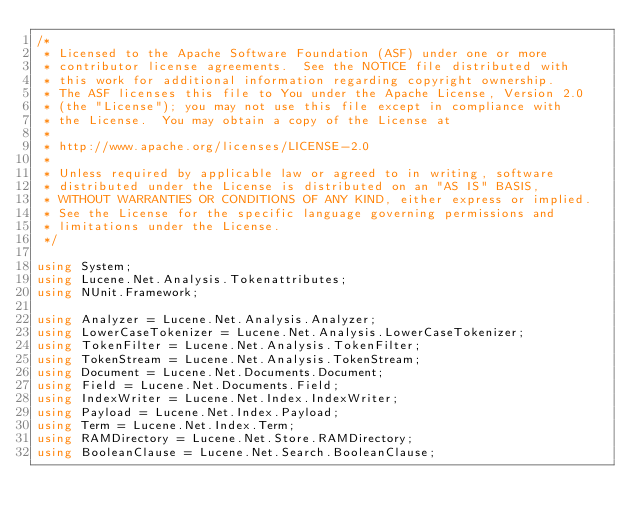Convert code to text. <code><loc_0><loc_0><loc_500><loc_500><_C#_>/* 
 * Licensed to the Apache Software Foundation (ASF) under one or more
 * contributor license agreements.  See the NOTICE file distributed with
 * this work for additional information regarding copyright ownership.
 * The ASF licenses this file to You under the Apache License, Version 2.0
 * (the "License"); you may not use this file except in compliance with
 * the License.  You may obtain a copy of the License at
 * 
 * http://www.apache.org/licenses/LICENSE-2.0
 * 
 * Unless required by applicable law or agreed to in writing, software
 * distributed under the License is distributed on an "AS IS" BASIS,
 * WITHOUT WARRANTIES OR CONDITIONS OF ANY KIND, either express or implied.
 * See the License for the specific language governing permissions and
 * limitations under the License.
 */

using System;
using Lucene.Net.Analysis.Tokenattributes;
using NUnit.Framework;

using Analyzer = Lucene.Net.Analysis.Analyzer;
using LowerCaseTokenizer = Lucene.Net.Analysis.LowerCaseTokenizer;
using TokenFilter = Lucene.Net.Analysis.TokenFilter;
using TokenStream = Lucene.Net.Analysis.TokenStream;
using Document = Lucene.Net.Documents.Document;
using Field = Lucene.Net.Documents.Field;
using IndexWriter = Lucene.Net.Index.IndexWriter;
using Payload = Lucene.Net.Index.Payload;
using Term = Lucene.Net.Index.Term;
using RAMDirectory = Lucene.Net.Store.RAMDirectory;
using BooleanClause = Lucene.Net.Search.BooleanClause;</code> 